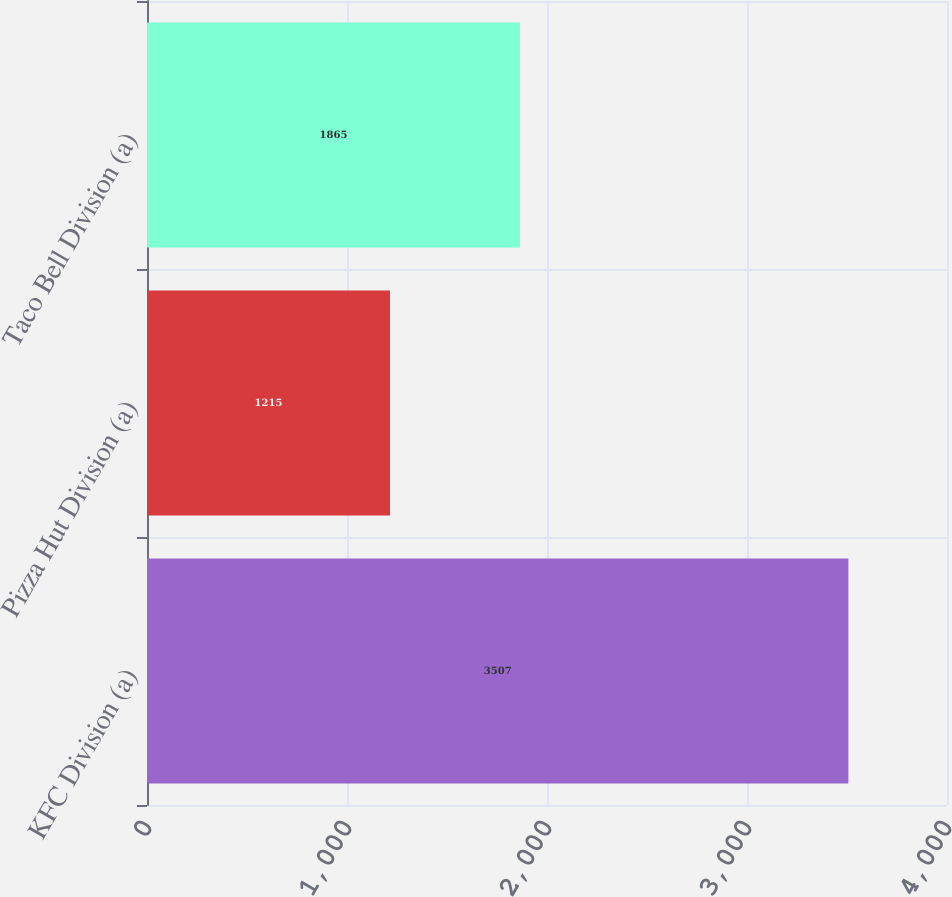<chart> <loc_0><loc_0><loc_500><loc_500><bar_chart><fcel>KFC Division (a)<fcel>Pizza Hut Division (a)<fcel>Taco Bell Division (a)<nl><fcel>3507<fcel>1215<fcel>1865<nl></chart> 